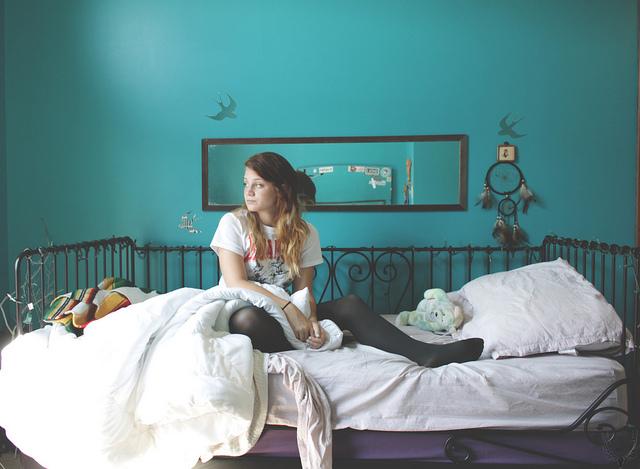What type of bed is the girl sitting on?
Quick response, please. Daybed. Where is a dream catcher located at in the picture?
Give a very brief answer. On wall. What color is the wall?
Give a very brief answer. Blue. Is this a recent photo?
Give a very brief answer. Yes. What size bed are they in?
Answer briefly. Twin. Is she on morphine?
Short answer required. No. 